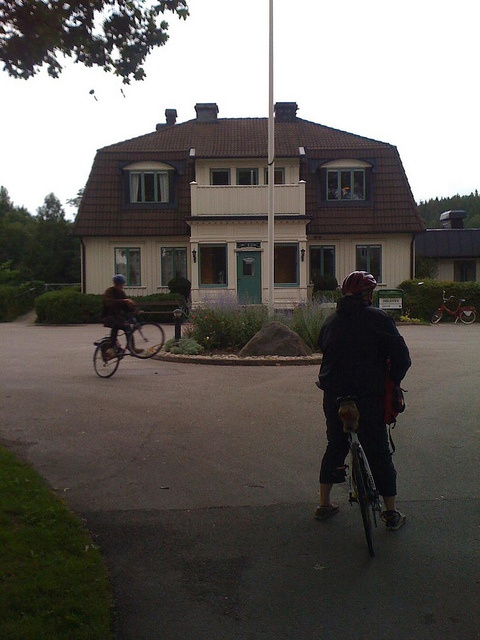Describe the objects in this image and their specific colors. I can see people in lightgray, black, and gray tones, bicycle in lightgray, black, and gray tones, bicycle in lightgray, black, and gray tones, people in lightgray, black, and gray tones, and backpack in lightgray, black, and gray tones in this image. 